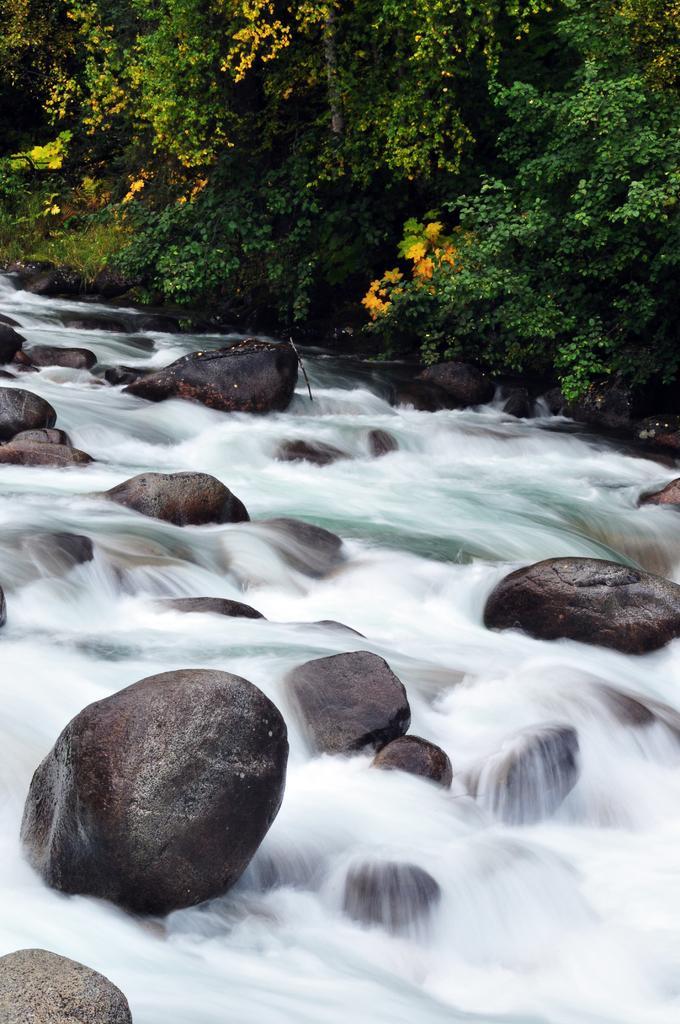Could you give a brief overview of what you see in this image? In this image there are trees, there are rocks, there is water flowing. 